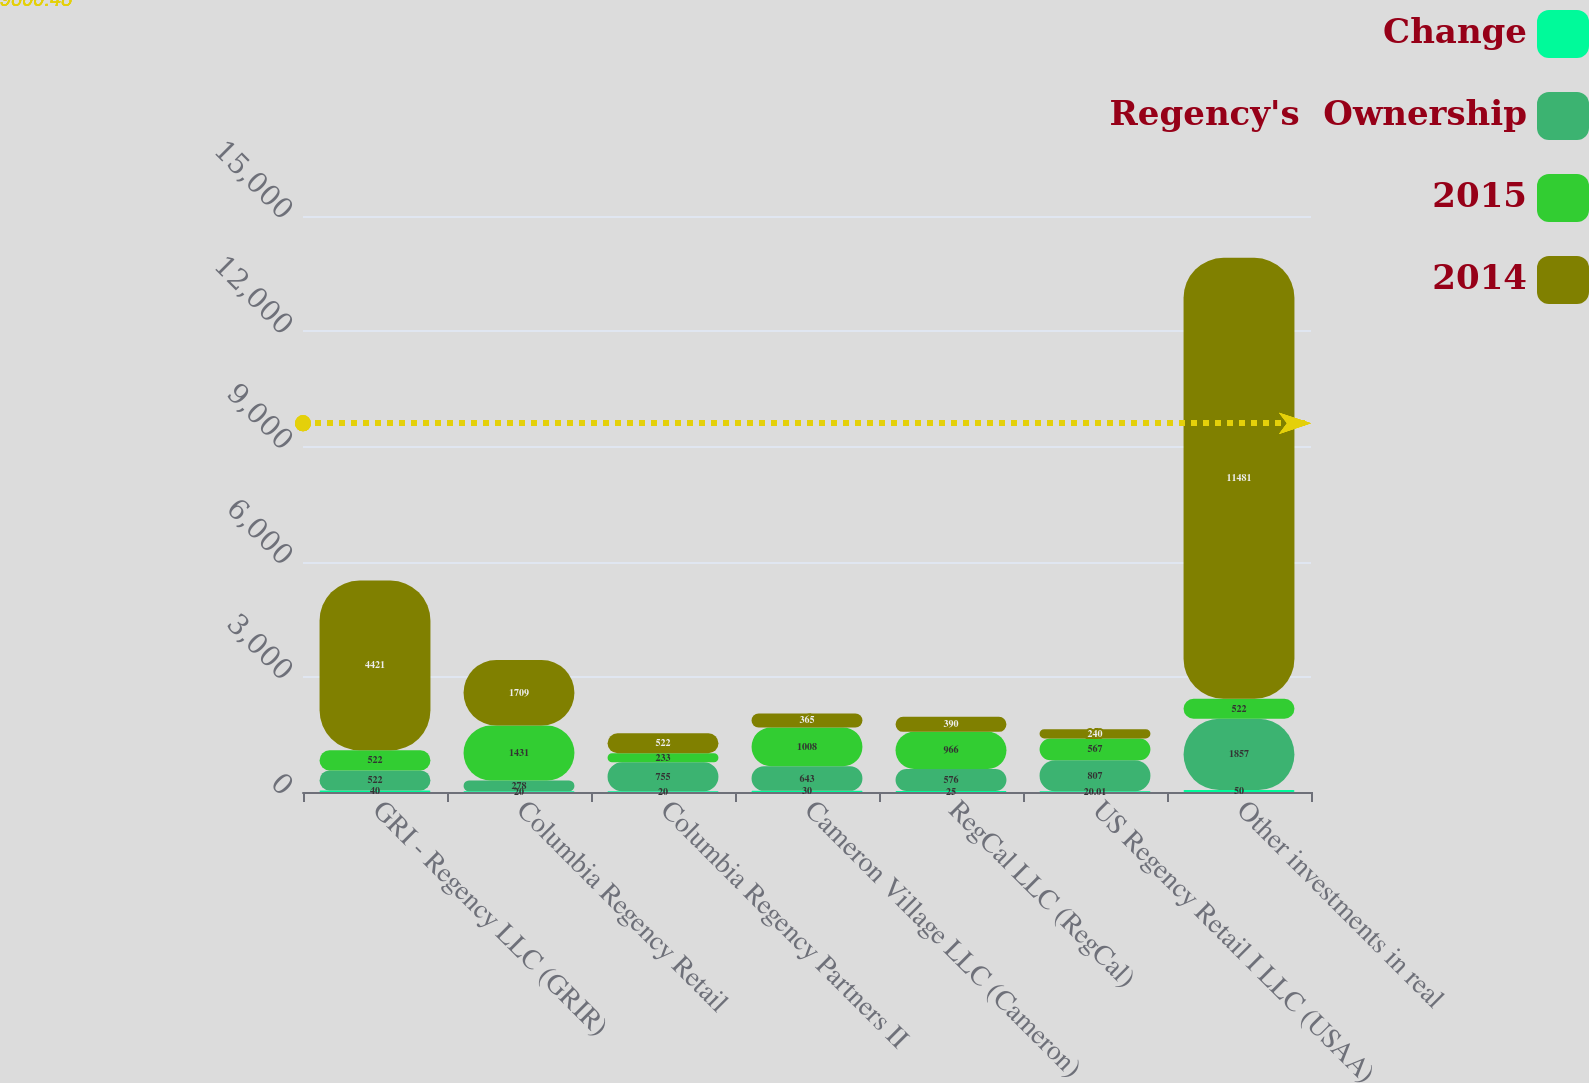<chart> <loc_0><loc_0><loc_500><loc_500><stacked_bar_chart><ecel><fcel>GRI - Regency LLC (GRIR)<fcel>Columbia Regency Retail<fcel>Columbia Regency Partners II<fcel>Cameron Village LLC (Cameron)<fcel>RegCal LLC (RegCal)<fcel>US Regency Retail I LLC (USAA)<fcel>Other investments in real<nl><fcel>Change<fcel>40<fcel>20<fcel>20<fcel>30<fcel>25<fcel>20.01<fcel>50<nl><fcel>Regency's  Ownership<fcel>522<fcel>278<fcel>755<fcel>643<fcel>576<fcel>807<fcel>1857<nl><fcel>2015<fcel>522<fcel>1431<fcel>233<fcel>1008<fcel>966<fcel>567<fcel>522<nl><fcel>2014<fcel>4421<fcel>1709<fcel>522<fcel>365<fcel>390<fcel>240<fcel>11481<nl></chart> 